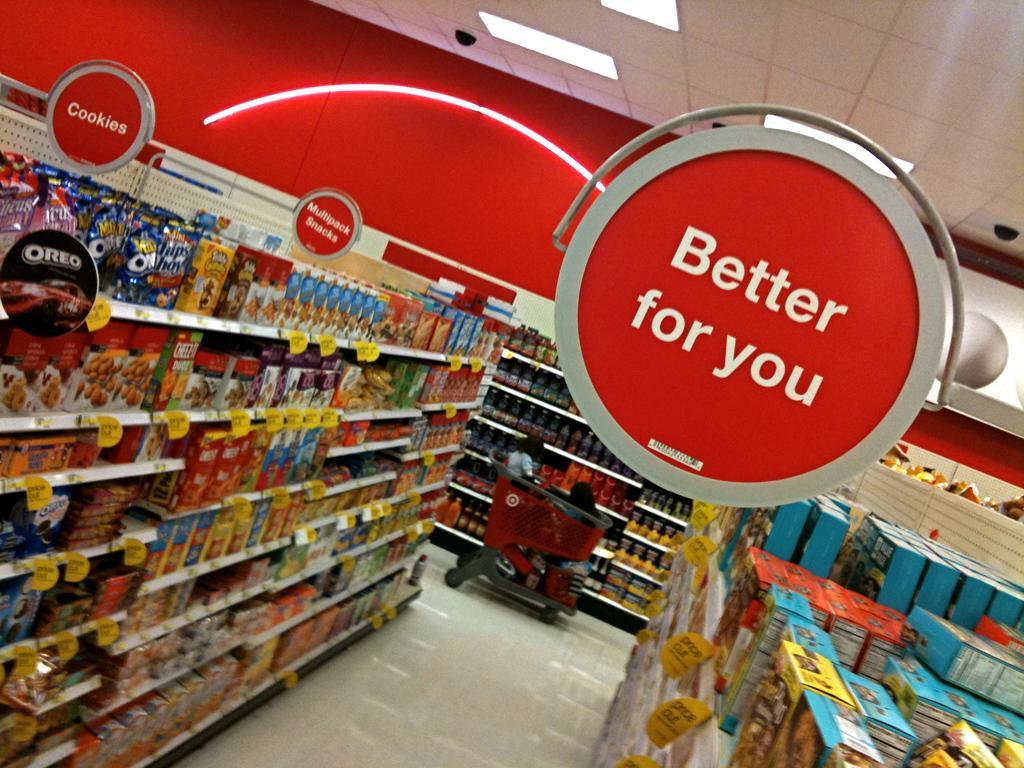Provide a one-sentence caption for the provided image. Red indoor sign that says "Better for you" is shown above cookies aisle. 